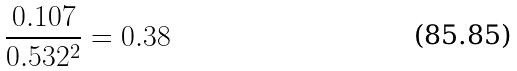<formula> <loc_0><loc_0><loc_500><loc_500>\frac { 0 . 1 0 7 } { 0 . 5 3 2 ^ { 2 } } = 0 . 3 8</formula> 